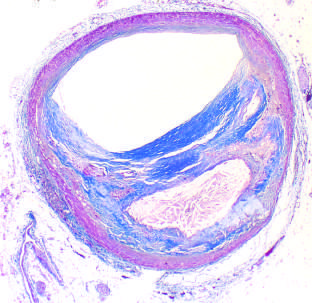re skin stem cells moderately narrowed by this eccentric lesion, which leaves part of the vessel wall unaffected?
Answer the question using a single word or phrase. No 